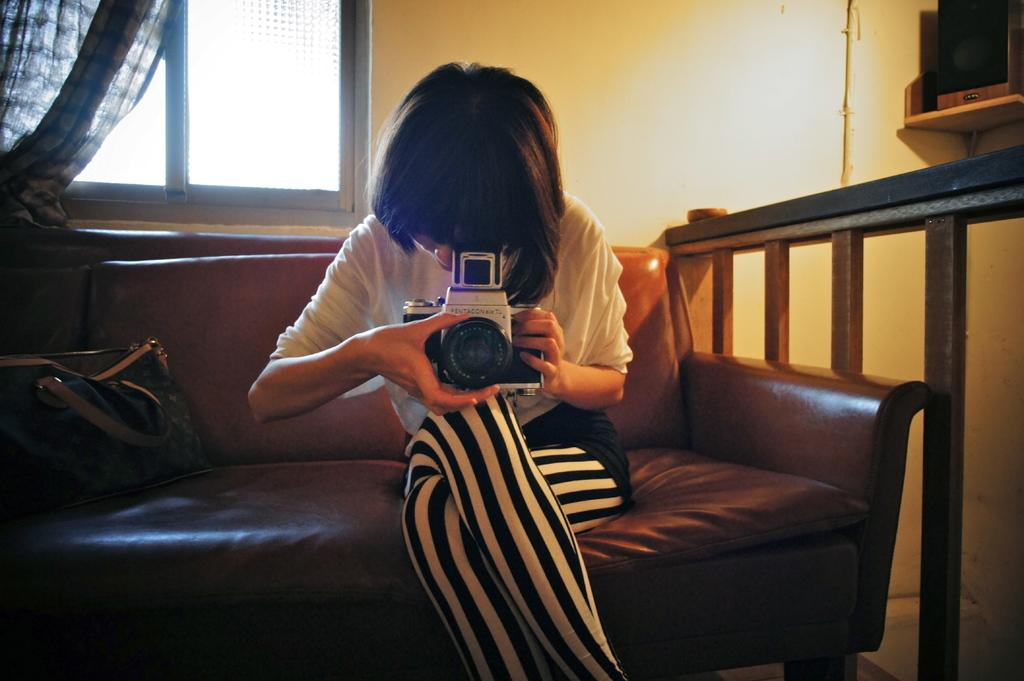Who is the main subject in the image? There is a girl in the image. What is the girl doing in the image? The girl is posing with a camera. Where is the girl sitting in the image? The girl is sitting on a couch. What can be seen in the background of the image? There is a window in the background of the image. What is associated with the window in the image? There is a window curtain associated with the window. What type of force can be seen acting on the goldfish in the image? There is no goldfish present in the image, so it is not possible to determine any forces acting on it. 